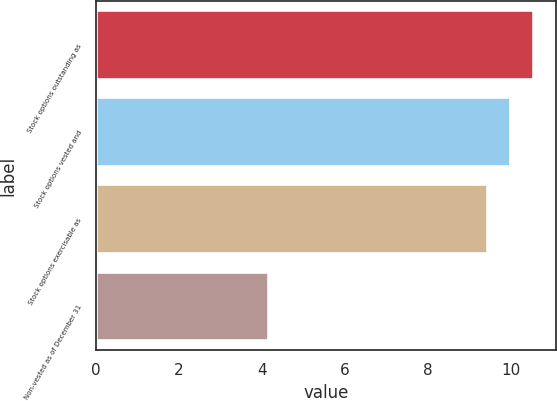Convert chart to OTSL. <chart><loc_0><loc_0><loc_500><loc_500><bar_chart><fcel>Stock options outstanding as<fcel>Stock options vested and<fcel>Stock options exercisable as<fcel>Non-vested as of December 31<nl><fcel>10.54<fcel>9.99<fcel>9.44<fcel>4.16<nl></chart> 